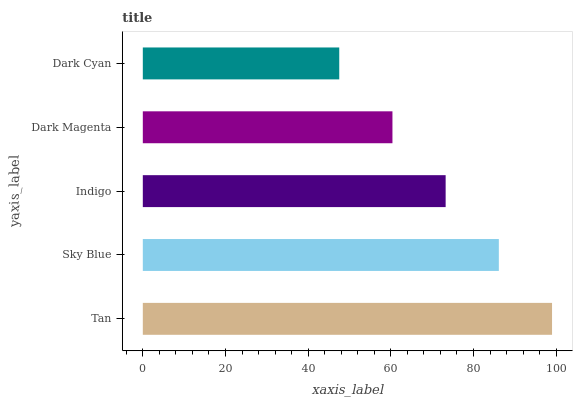Is Dark Cyan the minimum?
Answer yes or no. Yes. Is Tan the maximum?
Answer yes or no. Yes. Is Sky Blue the minimum?
Answer yes or no. No. Is Sky Blue the maximum?
Answer yes or no. No. Is Tan greater than Sky Blue?
Answer yes or no. Yes. Is Sky Blue less than Tan?
Answer yes or no. Yes. Is Sky Blue greater than Tan?
Answer yes or no. No. Is Tan less than Sky Blue?
Answer yes or no. No. Is Indigo the high median?
Answer yes or no. Yes. Is Indigo the low median?
Answer yes or no. Yes. Is Sky Blue the high median?
Answer yes or no. No. Is Dark Cyan the low median?
Answer yes or no. No. 